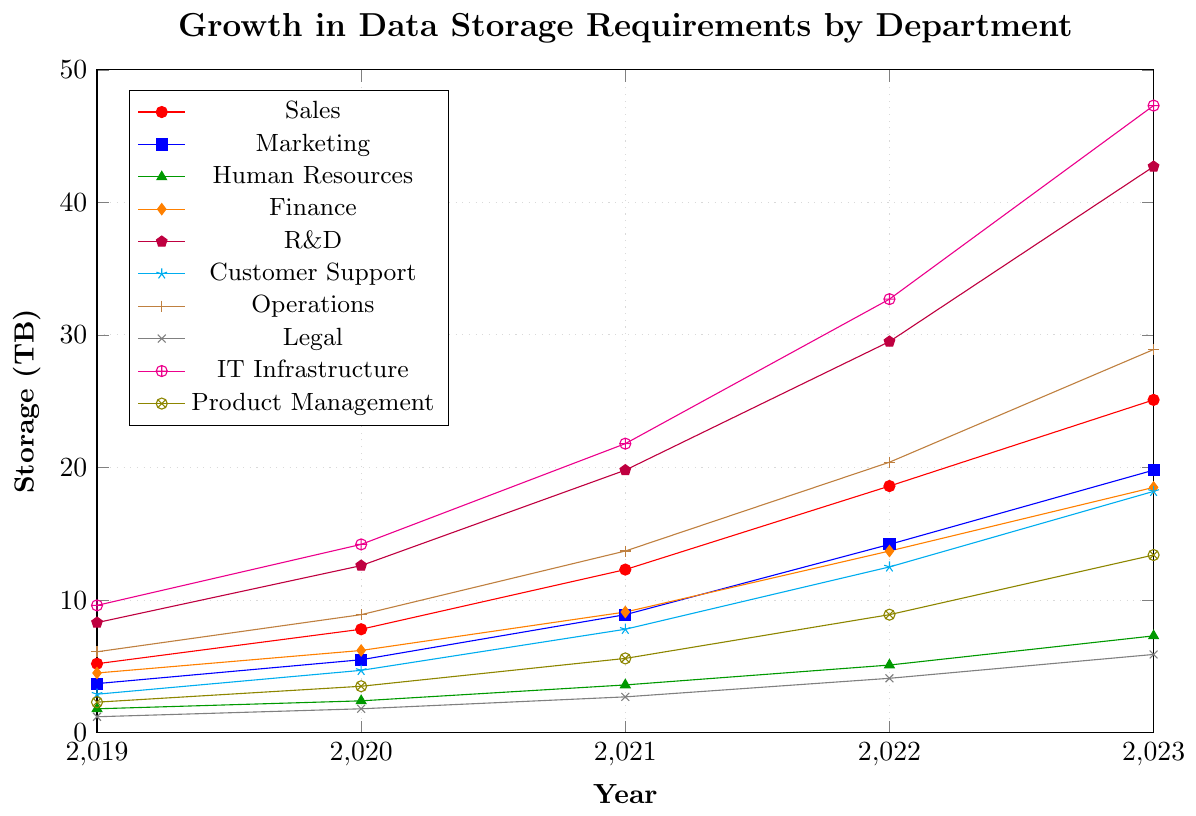Which department had the highest data storage requirement in 2023? The highest point on the y-axis for 2023 can be found in the IT Infrastructure department, reaching 47.3 TB.
Answer: IT Infrastructure Which department saw the highest growth in data storage requirement between 2019 and 2023? To determine the highest growth, calculate the difference between 2019 and 2023 for each department. IT Infrastructure went from 9.6 TB to 47.3 TB, showing the largest increase of 37.7 TB.
Answer: IT Infrastructure Compare the data storage requirements of Sales and Marketing in 2022. Which department required more storage? For 2022, Sales had 18.6 TB and Marketing had 14.2 TB. Comparing these values, Sales required more storage.
Answer: Sales What is the total data storage requirement for Finance from 2019 to 2023? Summing up Finance's data storage requirements from 2019 to 2023: 4.5 + 6.2 + 9.1 + 13.7 + 18.5 = 52 TB.
Answer: 52 TB In which year did Customer Support’s data storage requirement first exceed 10 TB? Looking at the plot for Customer Support, its data storage requirement first exceeded 10 TB in 2022 with 12.5 TB.
Answer: 2022 How much more storage did IT Infrastructure require compared to Legal in 2023? Subtract Legal's data storage in 2023 (5.9 TB) from IT Infrastructure's (47.3 TB). 47.3 - 5.9 = 41.4 TB.
Answer: 41.4 TB What is the average data storage requirement for the Human Resources department from 2019 to 2023? Sum HR's data storage requirements from 2019 to 2023 (1.8 + 2.4 + 3.6 + 5.1 + 7.3 = 20.2 TB), then divide by the number of years (5). 20.2 / 5 = 4.04 TB.
Answer: 4.04 TB Rank the departments by their data storage requirement in 2023 from highest to lowest. In 2023, the departments plot shows: IT Infrastructure (47.3 TB), R&D (42.7 TB), Operations (28.9 TB), Sales (25.1 TB), Marketing (19.8 TB), Finance (18.5 TB), Customer Support (18.2 TB), Product Management (13.4 TB), Human Resources (7.3 TB), Legal (5.9 TB)
Answer: IT Infrastructure, R&D, Operations, Sales, Marketing, Finance, Customer Support, Product Management, Human Resources, Legal Which departments had their data storage requirements double from 2019 to 2023? Check if the 2023 value is at least double the 2019 value for each department. The departments that meet this condition are Sales, Marketing, Finance, R&D, Customer Support, Operations, Legal, IT Infrastructure, and Product Management. Human Resources doesn’t quite double.
Answer: Sales, Marketing, Finance, R&D, Customer Support, Operations, Legal, IT Infrastructure, Product Management 